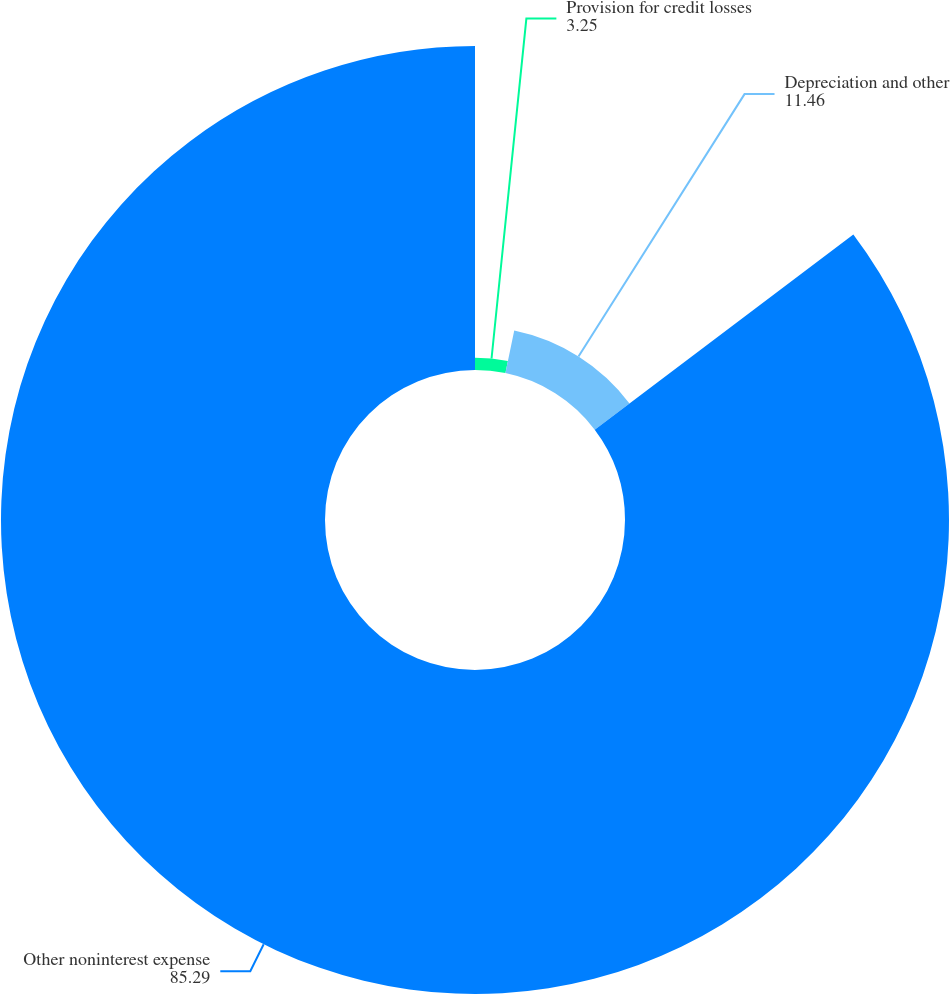Convert chart. <chart><loc_0><loc_0><loc_500><loc_500><pie_chart><fcel>Provision for credit losses<fcel>Depreciation and other<fcel>Other noninterest expense<nl><fcel>3.25%<fcel>11.46%<fcel>85.29%<nl></chart> 